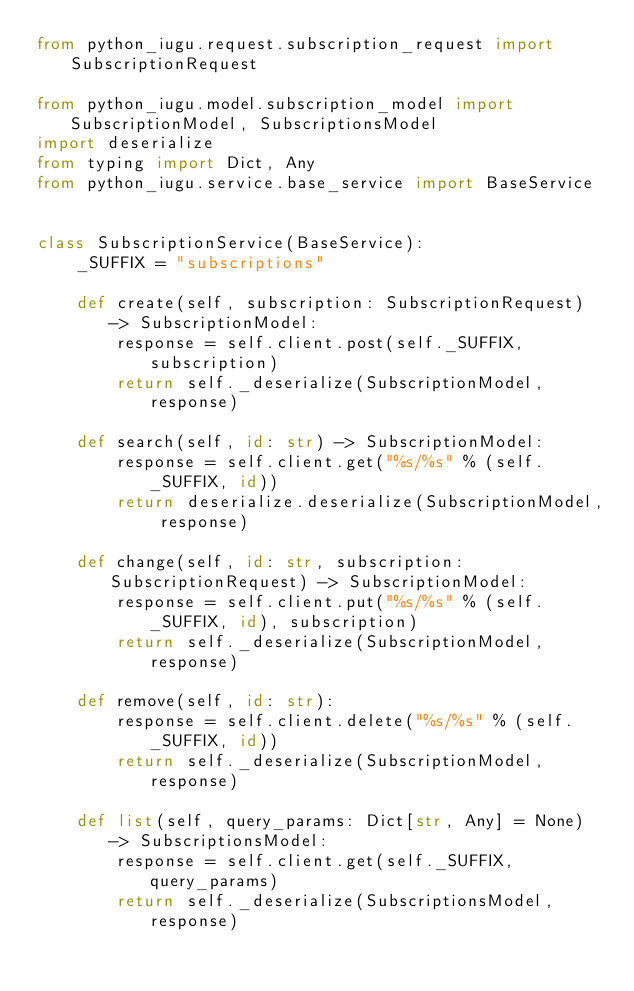<code> <loc_0><loc_0><loc_500><loc_500><_Python_>from python_iugu.request.subscription_request import SubscriptionRequest

from python_iugu.model.subscription_model import SubscriptionModel, SubscriptionsModel
import deserialize
from typing import Dict, Any
from python_iugu.service.base_service import BaseService


class SubscriptionService(BaseService):
    _SUFFIX = "subscriptions"

    def create(self, subscription: SubscriptionRequest) -> SubscriptionModel:
        response = self.client.post(self._SUFFIX, subscription)
        return self._deserialize(SubscriptionModel, response)

    def search(self, id: str) -> SubscriptionModel:
        response = self.client.get("%s/%s" % (self._SUFFIX, id))
        return deserialize.deserialize(SubscriptionModel, response)

    def change(self, id: str, subscription: SubscriptionRequest) -> SubscriptionModel:
        response = self.client.put("%s/%s" % (self._SUFFIX, id), subscription)
        return self._deserialize(SubscriptionModel, response)

    def remove(self, id: str):
        response = self.client.delete("%s/%s" % (self._SUFFIX, id))
        return self._deserialize(SubscriptionModel, response)

    def list(self, query_params: Dict[str, Any] = None) -> SubscriptionsModel:
        response = self.client.get(self._SUFFIX, query_params)
        return self._deserialize(SubscriptionsModel, response)
</code> 